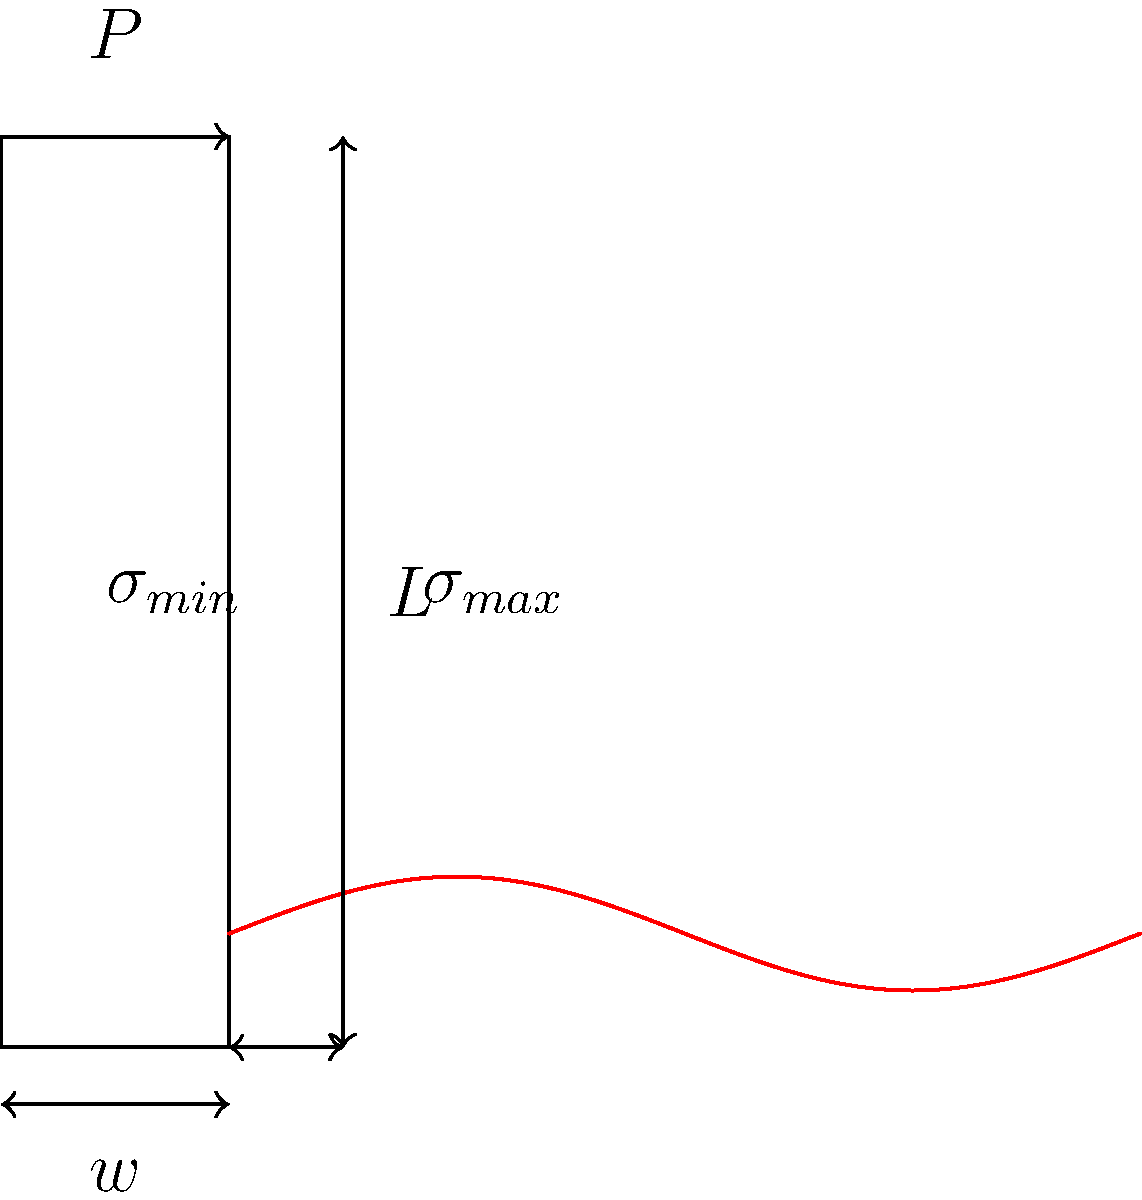A historical load-bearing column in your boutique hotel is subjected to an axial load $P$. The column has a height $L$ and width $w$. Given that the stress distribution along the column is non-uniform due to its age and material inconsistencies, as shown in the figure, what is the maximum stress $\sigma_{max}$ in terms of $P$, $w$, and the stress concentration factor $K$? To determine the maximum stress in the historical column, we need to follow these steps:

1. Understand the basic stress formula:
   The average stress in a column under axial load is given by:
   $$\sigma_{avg} = \frac{P}{A}$$
   where $A$ is the cross-sectional area of the column.

2. Calculate the cross-sectional area:
   For a rectangular column, $A = w \cdot t$, where $t$ is the thickness (not shown in the 2D representation).

3. Consider the stress concentration factor:
   Due to the non-uniform stress distribution, we introduce a stress concentration factor $K$. This factor relates the maximum stress to the average stress:
   $$\sigma_{max} = K \cdot \sigma_{avg}$$

4. Combine the equations:
   Substituting the average stress formula into the stress concentration equation:
   $$\sigma_{max} = K \cdot \frac{P}{w \cdot t}$$

5. Simplify:
   Since the thickness $t$ is not given in the problem, we can express the final equation in terms of $P$, $w$, and $K$:
   $$\sigma_{max} = \frac{K \cdot P}{w \cdot t}$$

This equation gives us the maximum stress in the historical column, taking into account the non-uniform stress distribution due to age and material inconsistencies.
Answer: $\sigma_{max} = \frac{K \cdot P}{w \cdot t}$ 